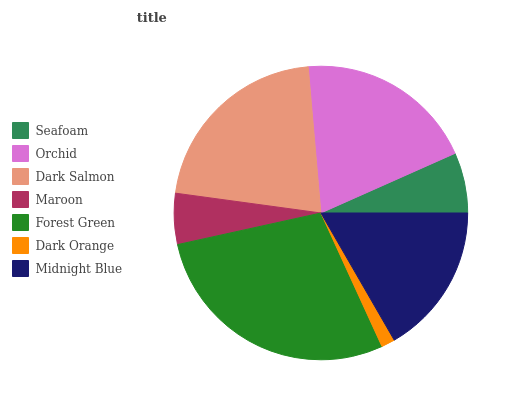Is Dark Orange the minimum?
Answer yes or no. Yes. Is Forest Green the maximum?
Answer yes or no. Yes. Is Orchid the minimum?
Answer yes or no. No. Is Orchid the maximum?
Answer yes or no. No. Is Orchid greater than Seafoam?
Answer yes or no. Yes. Is Seafoam less than Orchid?
Answer yes or no. Yes. Is Seafoam greater than Orchid?
Answer yes or no. No. Is Orchid less than Seafoam?
Answer yes or no. No. Is Midnight Blue the high median?
Answer yes or no. Yes. Is Midnight Blue the low median?
Answer yes or no. Yes. Is Forest Green the high median?
Answer yes or no. No. Is Orchid the low median?
Answer yes or no. No. 